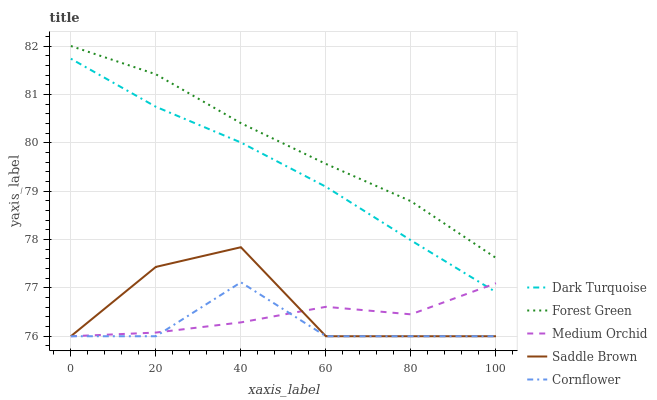Does Cornflower have the minimum area under the curve?
Answer yes or no. Yes. Does Forest Green have the maximum area under the curve?
Answer yes or no. Yes. Does Medium Orchid have the minimum area under the curve?
Answer yes or no. No. Does Medium Orchid have the maximum area under the curve?
Answer yes or no. No. Is Dark Turquoise the smoothest?
Answer yes or no. Yes. Is Saddle Brown the roughest?
Answer yes or no. Yes. Is Forest Green the smoothest?
Answer yes or no. No. Is Forest Green the roughest?
Answer yes or no. No. Does Medium Orchid have the lowest value?
Answer yes or no. Yes. Does Forest Green have the lowest value?
Answer yes or no. No. Does Forest Green have the highest value?
Answer yes or no. Yes. Does Medium Orchid have the highest value?
Answer yes or no. No. Is Medium Orchid less than Forest Green?
Answer yes or no. Yes. Is Forest Green greater than Cornflower?
Answer yes or no. Yes. Does Cornflower intersect Medium Orchid?
Answer yes or no. Yes. Is Cornflower less than Medium Orchid?
Answer yes or no. No. Is Cornflower greater than Medium Orchid?
Answer yes or no. No. Does Medium Orchid intersect Forest Green?
Answer yes or no. No. 